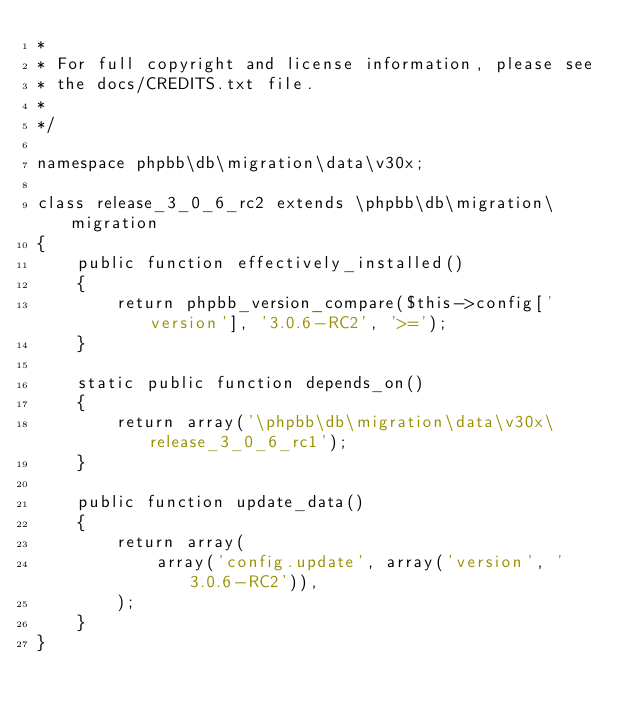Convert code to text. <code><loc_0><loc_0><loc_500><loc_500><_PHP_>*
* For full copyright and license information, please see
* the docs/CREDITS.txt file.
*
*/

namespace phpbb\db\migration\data\v30x;

class release_3_0_6_rc2 extends \phpbb\db\migration\migration
{
	public function effectively_installed()
	{
		return phpbb_version_compare($this->config['version'], '3.0.6-RC2', '>=');
	}

	static public function depends_on()
	{
		return array('\phpbb\db\migration\data\v30x\release_3_0_6_rc1');
	}

	public function update_data()
	{
		return array(
			array('config.update', array('version', '3.0.6-RC2')),
		);
	}
}
</code> 